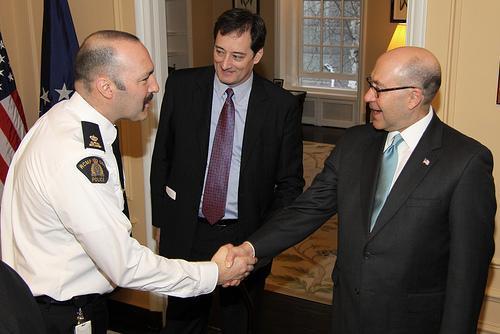How many people are wearing a jacket?
Give a very brief answer. 2. 